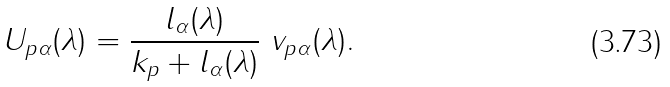Convert formula to latex. <formula><loc_0><loc_0><loc_500><loc_500>U _ { p \alpha } ( \lambda ) = \frac { l _ { \alpha } ( \lambda ) } { k _ { p } + l _ { \alpha } ( \lambda ) } \ v _ { p \alpha } ( \lambda ) .</formula> 